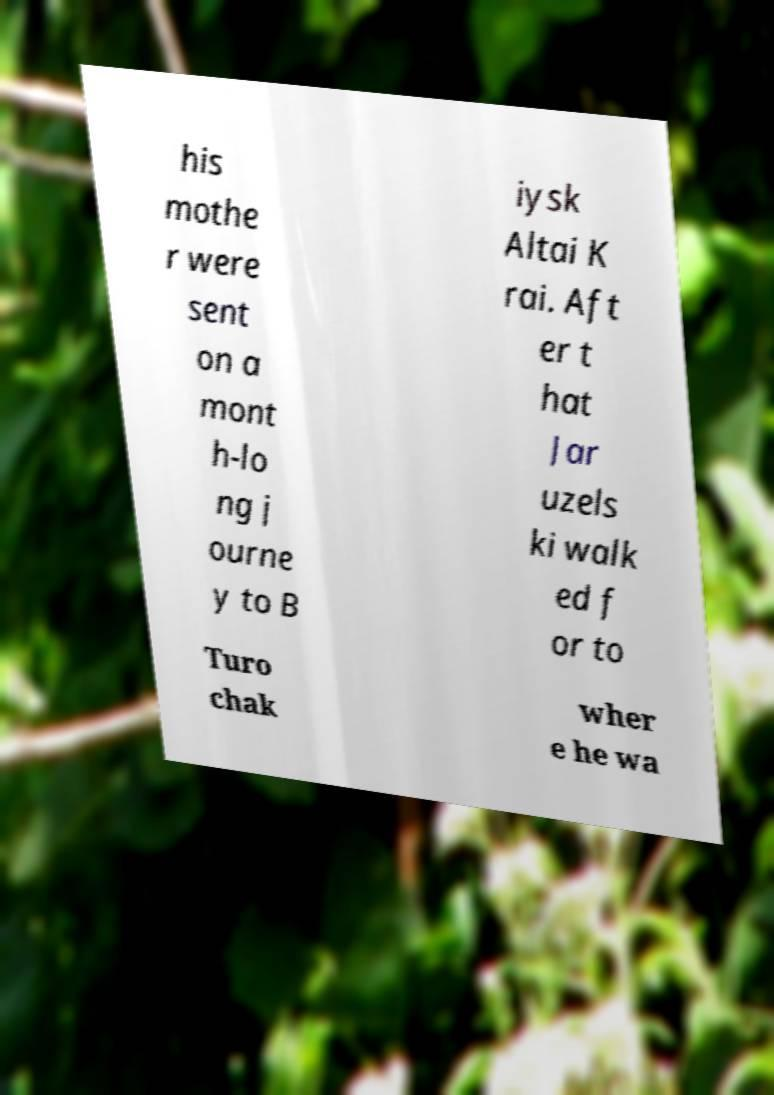Could you extract and type out the text from this image? his mothe r were sent on a mont h-lo ng j ourne y to B iysk Altai K rai. Aft er t hat Jar uzels ki walk ed f or to Turo chak wher e he wa 